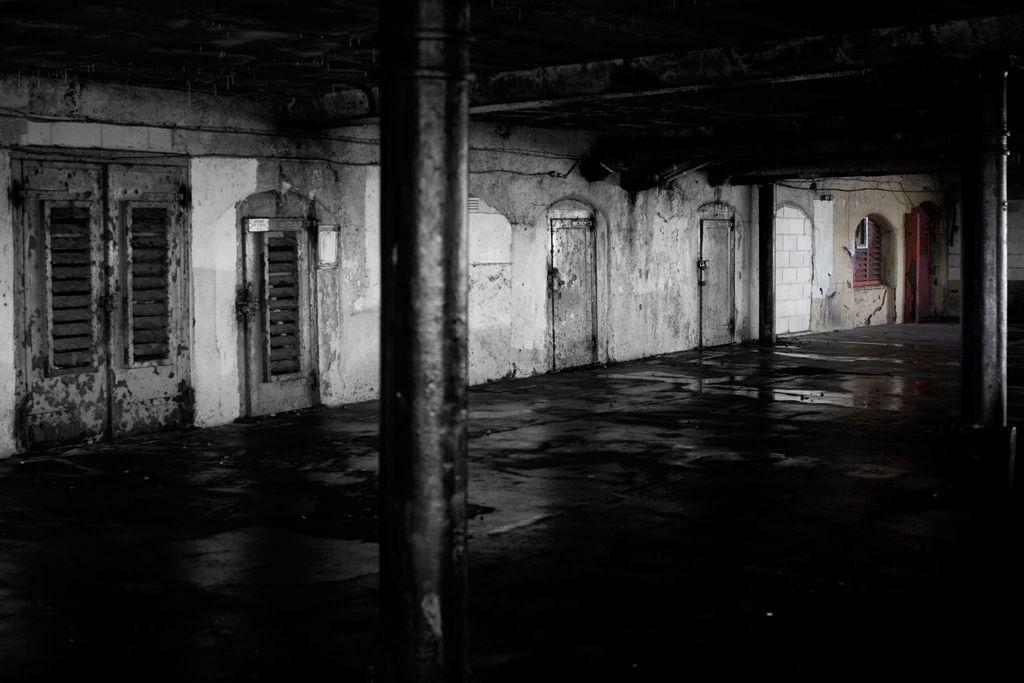What type of location is depicted in the image? The image is an inside picture of a building. What architectural features can be seen in the image? There are doors, a window, a wall, and pillars in the image. What type of dinner is being served in the image? There is no dinner present in the image. 